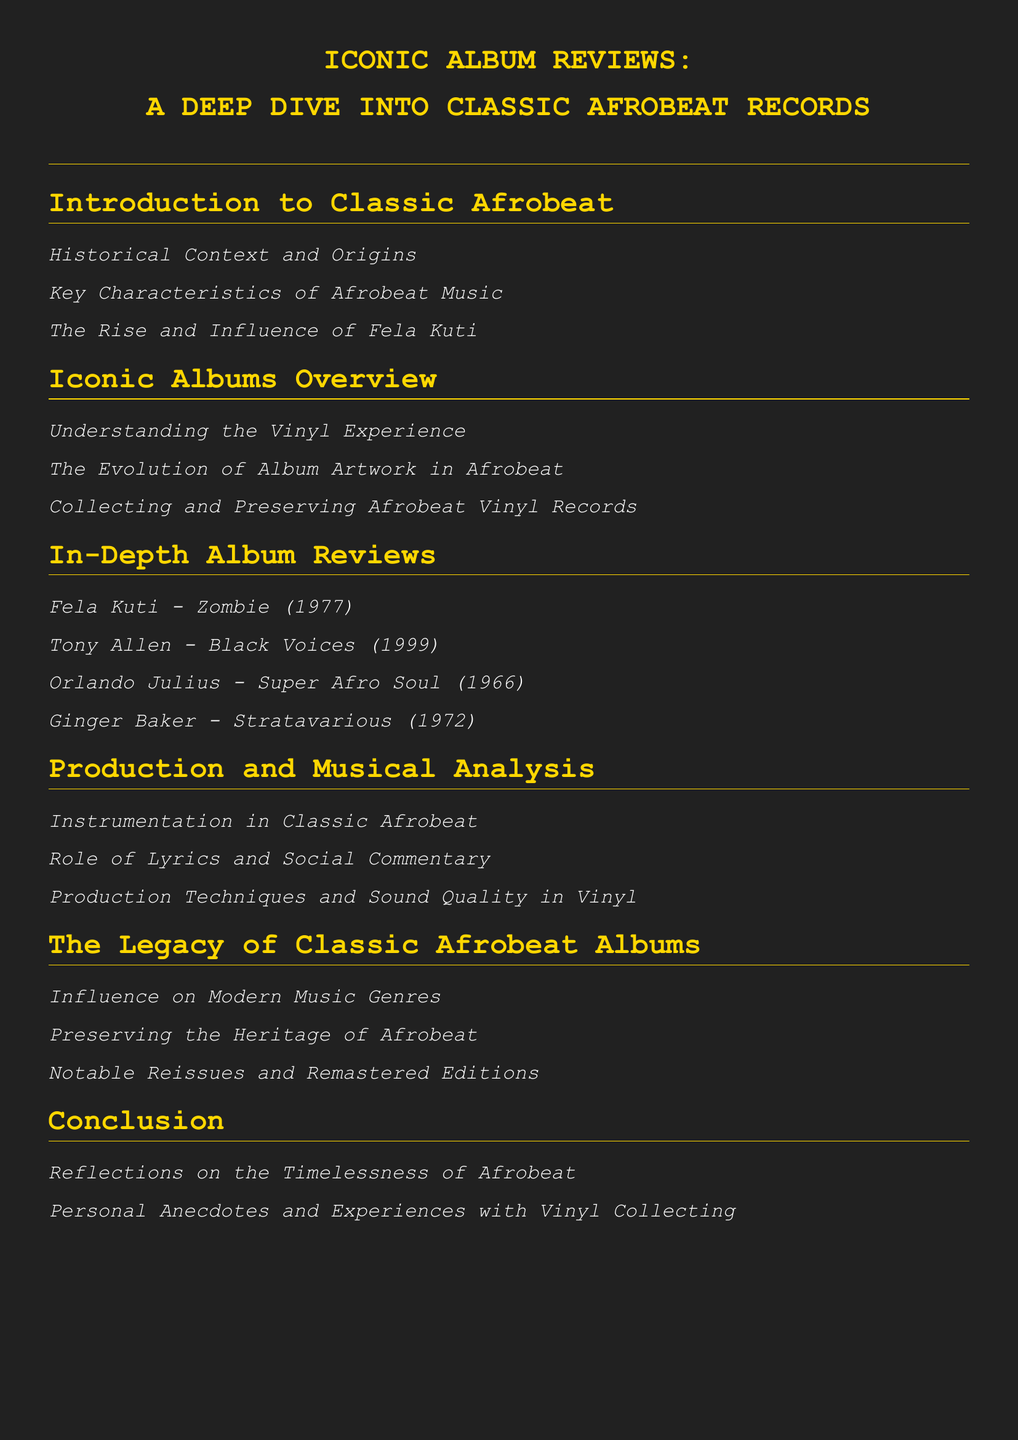What are the key characteristics of Afrobeat music? This information can be found in the section titled "Key Characteristics of Afrobeat Music" under "Introduction to Classic Afrobeat."
Answer: Key Characteristics of Afrobeat Music Which year was Fela Kuti's album "Zombie" released? The year of release is mentioned in the section "In-Depth Album Reviews" for "Fela Kuti - Zombie."
Answer: 1977 What is the title of Tony Allen's album reviewed in the document? This can be found under the "In-Depth Album Reviews" section related to Tony Allen.
Answer: Black Voices How many albums are reviewed in the "In-Depth Album Reviews" section? The total number of albums listed in the section indicates the count based on the mentioned titles.
Answer: Four What is discussed in the "Instrumentation in Classic Afrobeat" section? This section focuses on the specific aspect of instrumentation within the genre of Afrobeat and is under "Production and Musical Analysis."
Answer: Instrumentation in Classic Afrobeat Who is mentioned as a notable figure influencing Afrobeat music? This is found in the "The Rise and Influence of Fela Kuti" subsection under "Introduction to Classic Afrobeat."
Answer: Fela Kuti What does the "Conclusion" section emphasize about Afrobeat? The main focus of the Conclusion relates to the overarching theme about Afrobeat's enduring quality discussed in that section.
Answer: Timelessness of Afrobeat What does the document suggest about preserving Afrobeat? This is found in the subsection "Preserving the Heritage of Afrobeat" under "The Legacy of Classic Afrobeat Albums."
Answer: Preserving the Heritage of Afrobeat 